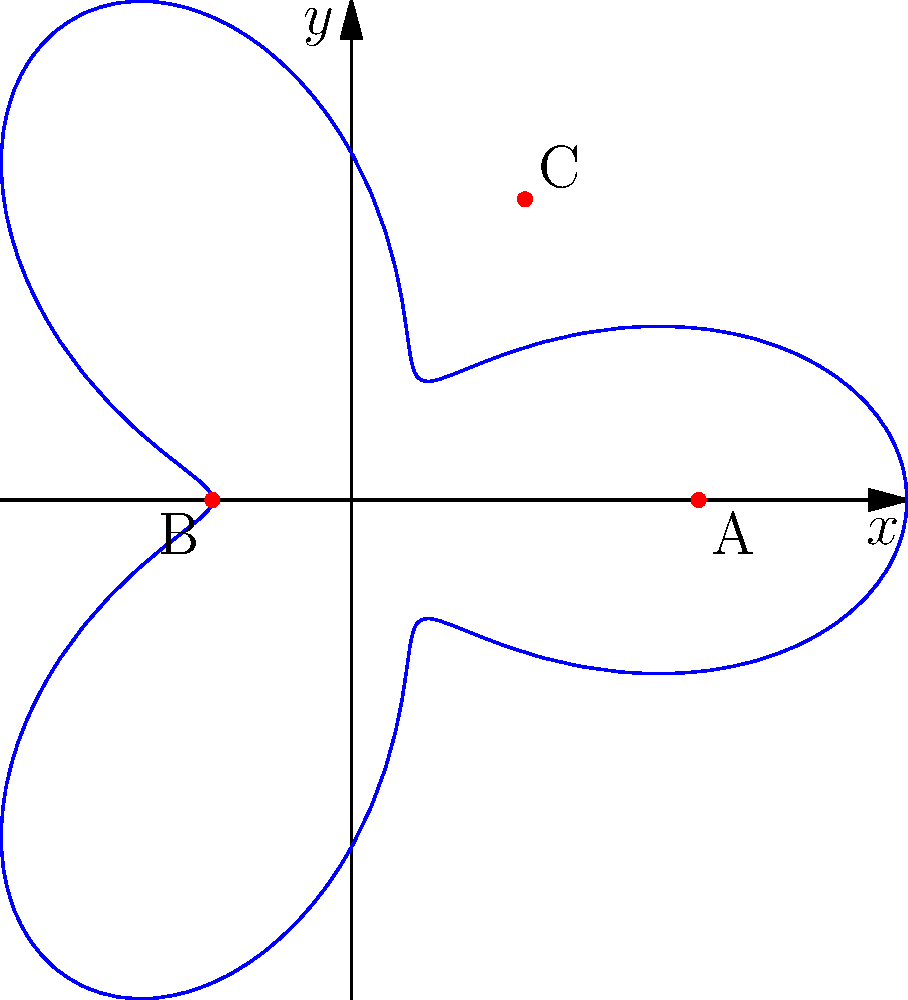In mapping ancient Sami sacred sites, you're using polar coordinates to represent the locations. The curve shown represents a region of interest, described by the equation $r = 5 + 3\cos(3\theta)$. Three significant sites are marked: A(5,0), B(-2,0), and C(2.5,4.33). Which of these sites has polar coordinates closest to $(r,\theta) = (5,\frac{\pi}{3})$? To solve this problem, we need to convert the Cartesian coordinates of each point to polar coordinates and compare them with $(5,\frac{\pi}{3})$. Let's go through this step-by-step:

1) For point A(5,0):
   $r = \sqrt{5^2 + 0^2} = 5$
   $\theta = \arctan(\frac{0}{5}) = 0$
   Polar coordinates: $(5,0)$

2) For point B(-2,0):
   $r = \sqrt{(-2)^2 + 0^2} = 2$
   $\theta = \arctan(\frac{0}{-2}) + \pi = \pi$
   Polar coordinates: $(2,\pi)$

3) For point C(2.5,4.33):
   $r = \sqrt{2.5^2 + 4.33^2} \approx 5$
   $\theta = \arctan(\frac{4.33}{2.5}) \approx 1.05 \approx \frac{\pi}{3}$
   Polar coordinates: $(5,\frac{\pi}{3})$

4) The given point has polar coordinates $(5,\frac{\pi}{3})$

Comparing these results, we can see that point C has polar coordinates almost exactly matching $(5,\frac{\pi}{3})$.
Answer: C 